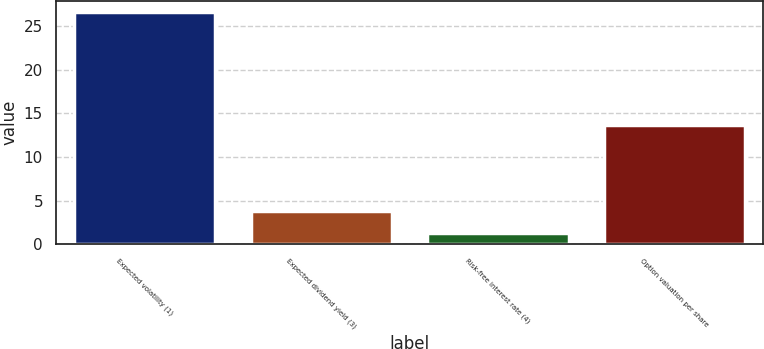<chart> <loc_0><loc_0><loc_500><loc_500><bar_chart><fcel>Expected volatility (1)<fcel>Expected dividend yield (3)<fcel>Risk-free interest rate (4)<fcel>Option valuation per share<nl><fcel>26.6<fcel>3.82<fcel>1.29<fcel>13.68<nl></chart> 